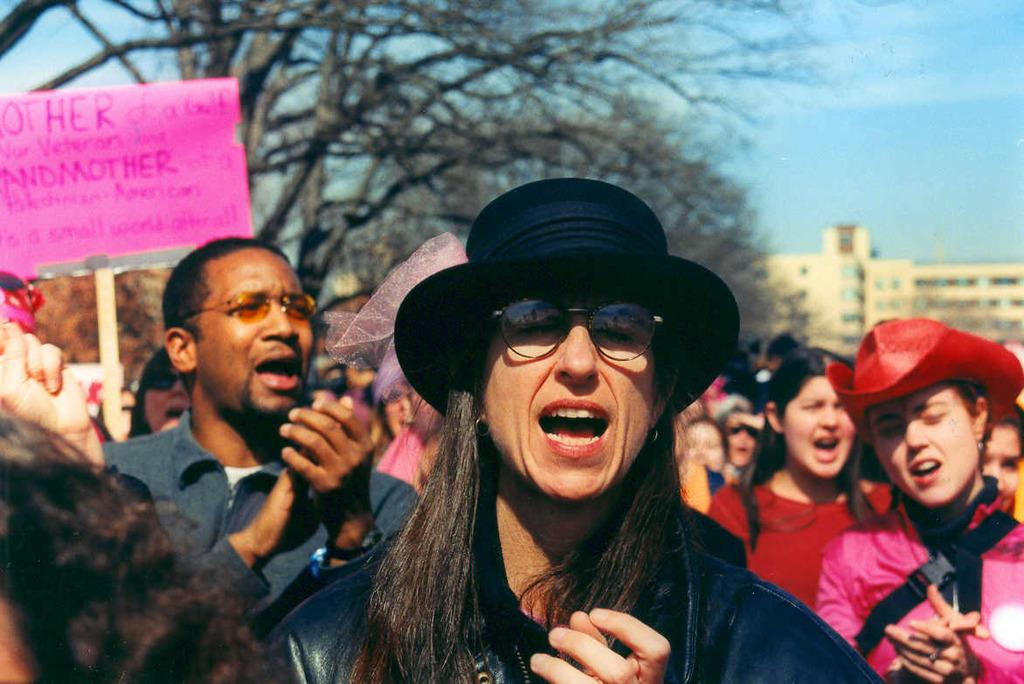How many people are in the image? There are people in the image, but the exact number is not specified. What is one person holding in the image? One person is holding a board with written text. What type of natural vegetation can be seen in the image? There are trees in the image. What type of structure is visible in the image? There is a building in the image. What is visible in the background of the image? The sky is visible in the image. Can you see a person using a knife to cut a volcano in the image? No, there is no person using a knife to cut a volcano in the image. 